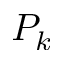Convert formula to latex. <formula><loc_0><loc_0><loc_500><loc_500>P _ { k }</formula> 